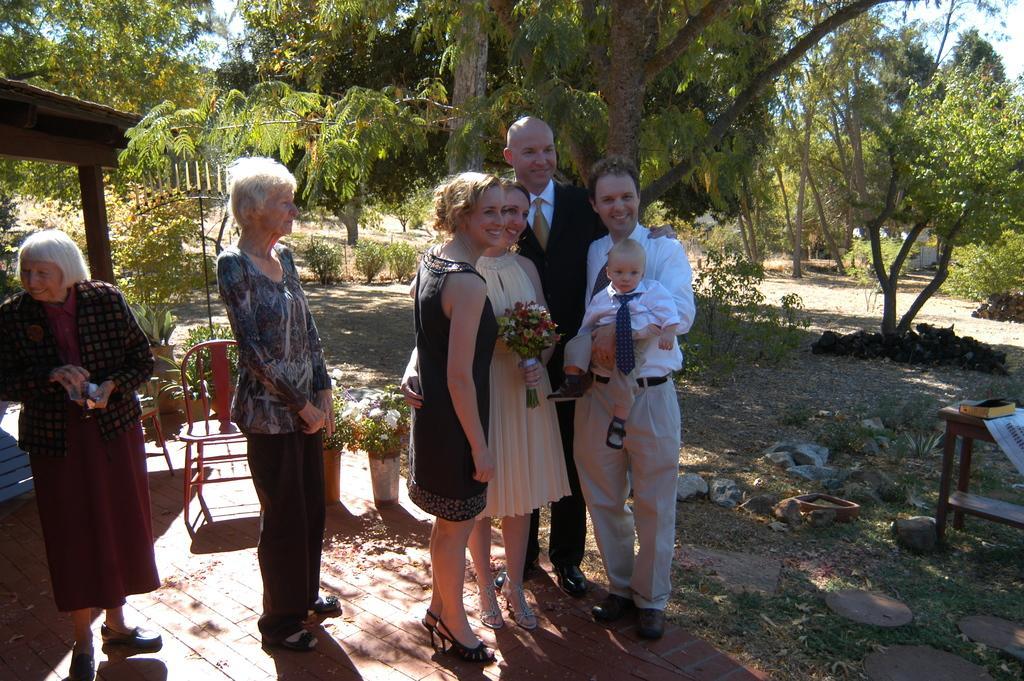In one or two sentences, can you explain what this image depicts? In this picture we can see a group of people standing on the ground and smiling, houseplants, chair, table, book, stones, grass, trees and in the background we can see the sky. 